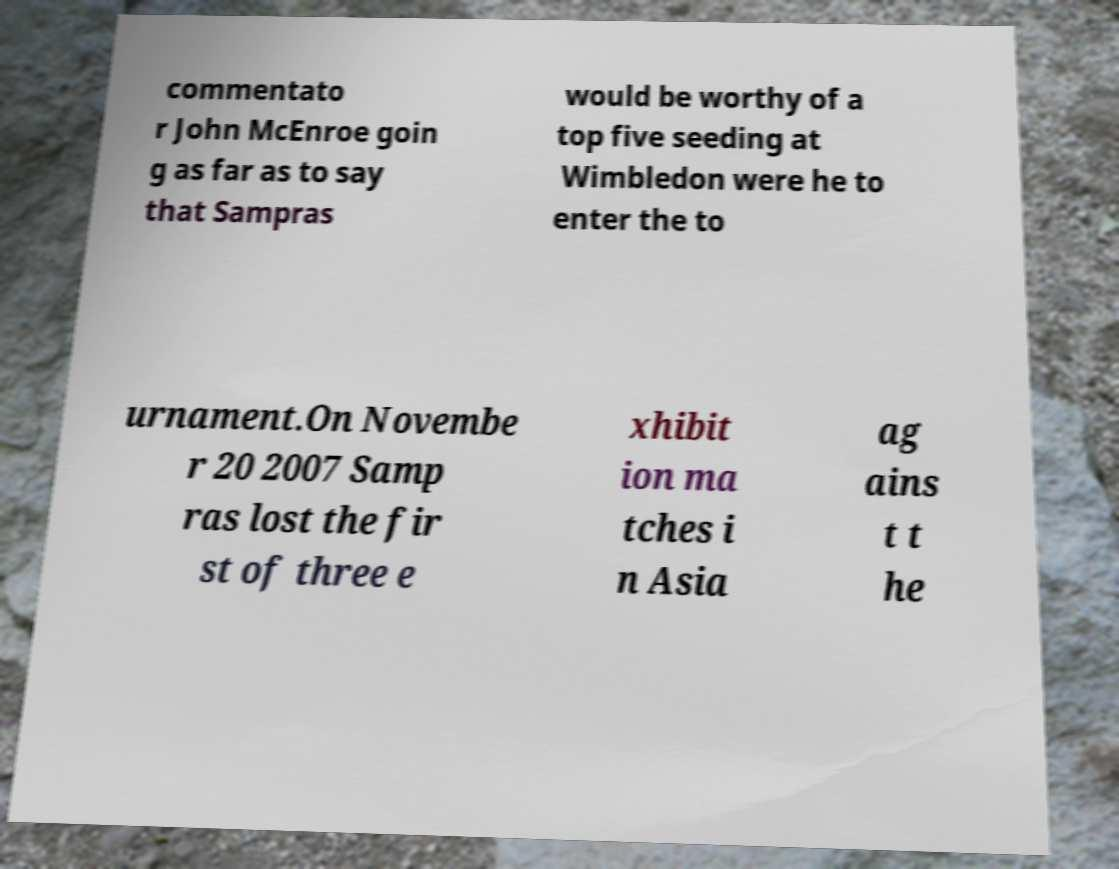Could you assist in decoding the text presented in this image and type it out clearly? commentato r John McEnroe goin g as far as to say that Sampras would be worthy of a top five seeding at Wimbledon were he to enter the to urnament.On Novembe r 20 2007 Samp ras lost the fir st of three e xhibit ion ma tches i n Asia ag ains t t he 